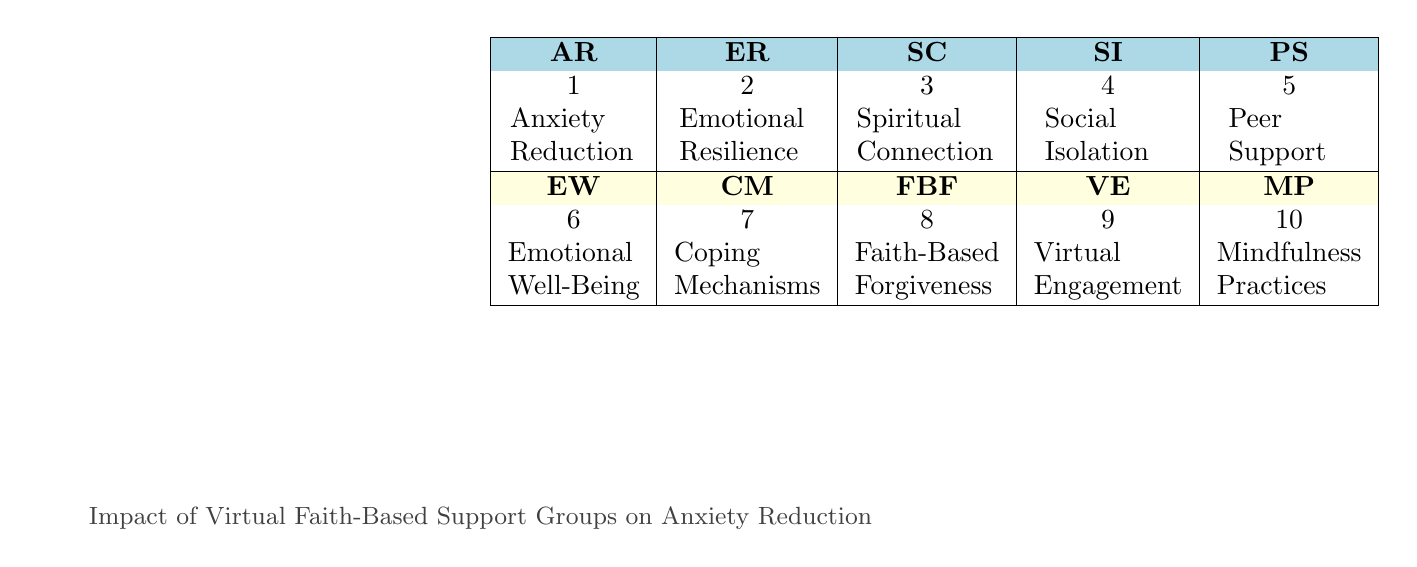What is the symbol for Emotional Resilience? The table lists the symbol for Emotional Resilience as "ER". This can be found in the row where Emotional Resilience is mentioned.
Answer: ER Which element corresponds to the atomic number 3? The element with atomic number 3 is Spiritual Connection. This is directly retrievable from the table where atomic numbers are paired with the respective elements.
Answer: Spiritual Connection Is Faith-Based Forgiveness associated with reducing anxiety? Yes, Faith-Based Forgiveness is listed in the table and is described as the process of letting go of negative emotions, which can contribute to overall emotional health, thus indicating a relationship with anxiety reduction.
Answer: Yes What is the combined atomic number of Coping Mechanisms and Mindfulness Practices? To find the combined atomic number, we locate Coping Mechanisms and Mindfulness Practices, which correspond to atomic numbers 7 and 10, respectively. Adding them together gives 7 + 10 = 17.
Answer: 17 Does Virtual Engagement enhance feelings of community? Yes, the description for Virtual Engagement in the table states that it enhances feelings of community and belonging, indicating its positive influence.
Answer: Yes Which element has the greatest atomic number in the table? The element with the greatest atomic number is Mindfulness Practices, which has an atomic number of 10. This is found by scanning through all the atomic numbers listed in the table.
Answer: 10 How many elements in the table relate to reducing anxiety? Five elements directly relate to reducing anxiety: Anxiety Reduction, Peer Support, Emotional Resilience, Coping Mechanisms, and Mindfulness Practices. This is identified by reviewing the descriptions of each element to check for their connection to anxiety.
Answer: 5 What is the difference in atomic numbers between Spiritual Connection and Social Isolation? The atomic number of Spiritual Connection is 3 and for Social Isolation is 4. The difference is calculated as 4 - 3 = 1.
Answer: 1 Do emotional well-being and peer support share any common attributes? Yes, both are suggested to be influenced positively by virtual interactions and support, as indicated in their descriptions, implying they share common attributes related to emotional health.
Answer: Yes 